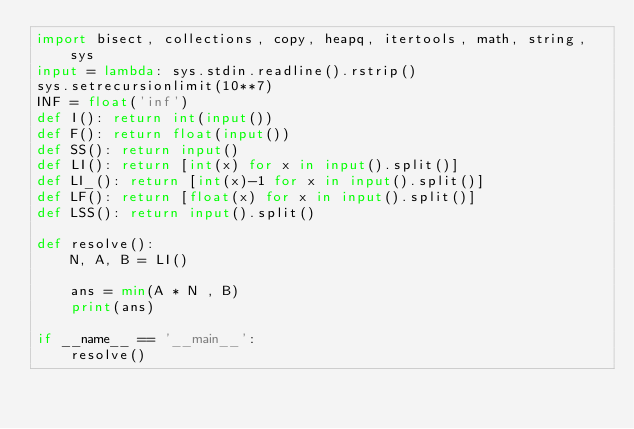Convert code to text. <code><loc_0><loc_0><loc_500><loc_500><_Python_>import bisect, collections, copy, heapq, itertools, math, string, sys
input = lambda: sys.stdin.readline().rstrip() 
sys.setrecursionlimit(10**7)
INF = float('inf')
def I(): return int(input())
def F(): return float(input())
def SS(): return input()
def LI(): return [int(x) for x in input().split()]
def LI_(): return [int(x)-1 for x in input().split()]
def LF(): return [float(x) for x in input().split()]
def LSS(): return input().split()

def resolve():
    N, A, B = LI()

    ans = min(A * N , B)
    print(ans)

if __name__ == '__main__':
    resolve()
</code> 